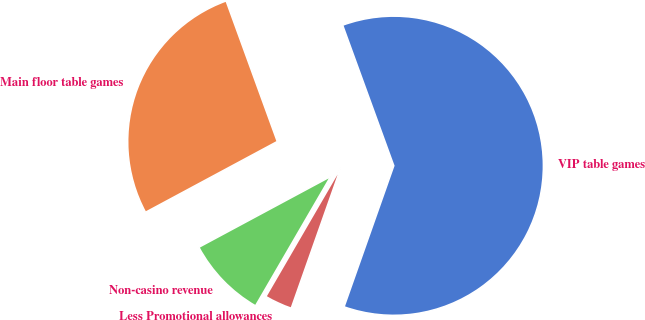Convert chart to OTSL. <chart><loc_0><loc_0><loc_500><loc_500><pie_chart><fcel>VIP table games<fcel>Main floor table games<fcel>Non-casino revenue<fcel>Less Promotional allowances<nl><fcel>60.95%<fcel>27.29%<fcel>8.78%<fcel>2.98%<nl></chart> 